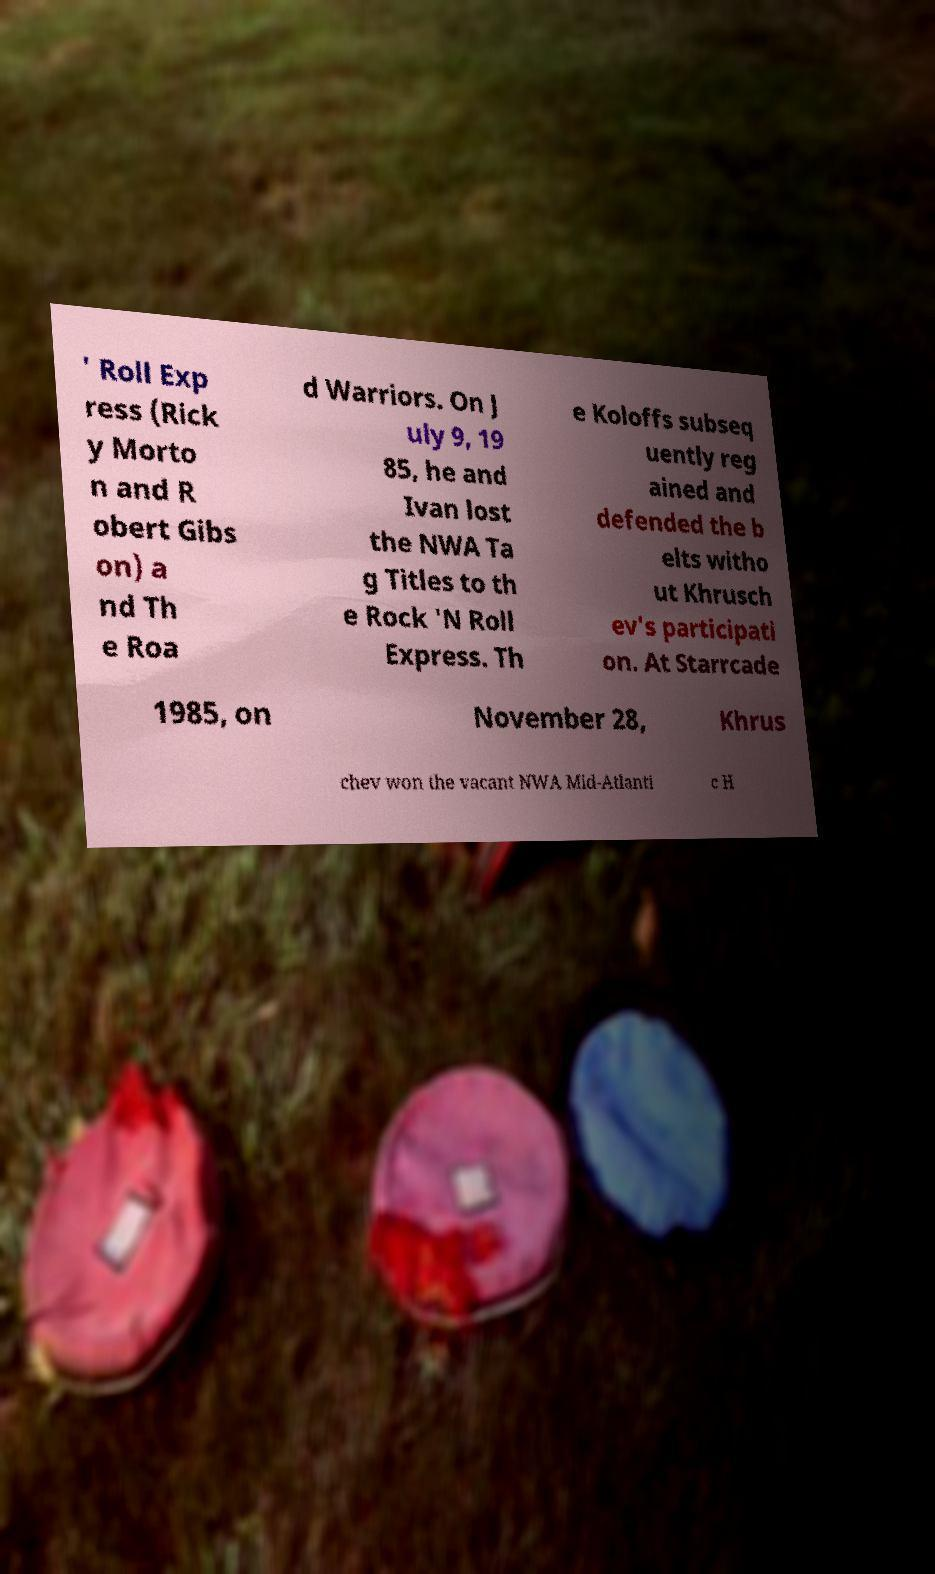Can you accurately transcribe the text from the provided image for me? ' Roll Exp ress (Rick y Morto n and R obert Gibs on) a nd Th e Roa d Warriors. On J uly 9, 19 85, he and Ivan lost the NWA Ta g Titles to th e Rock 'N Roll Express. Th e Koloffs subseq uently reg ained and defended the b elts witho ut Khrusch ev's participati on. At Starrcade 1985, on November 28, Khrus chev won the vacant NWA Mid-Atlanti c H 